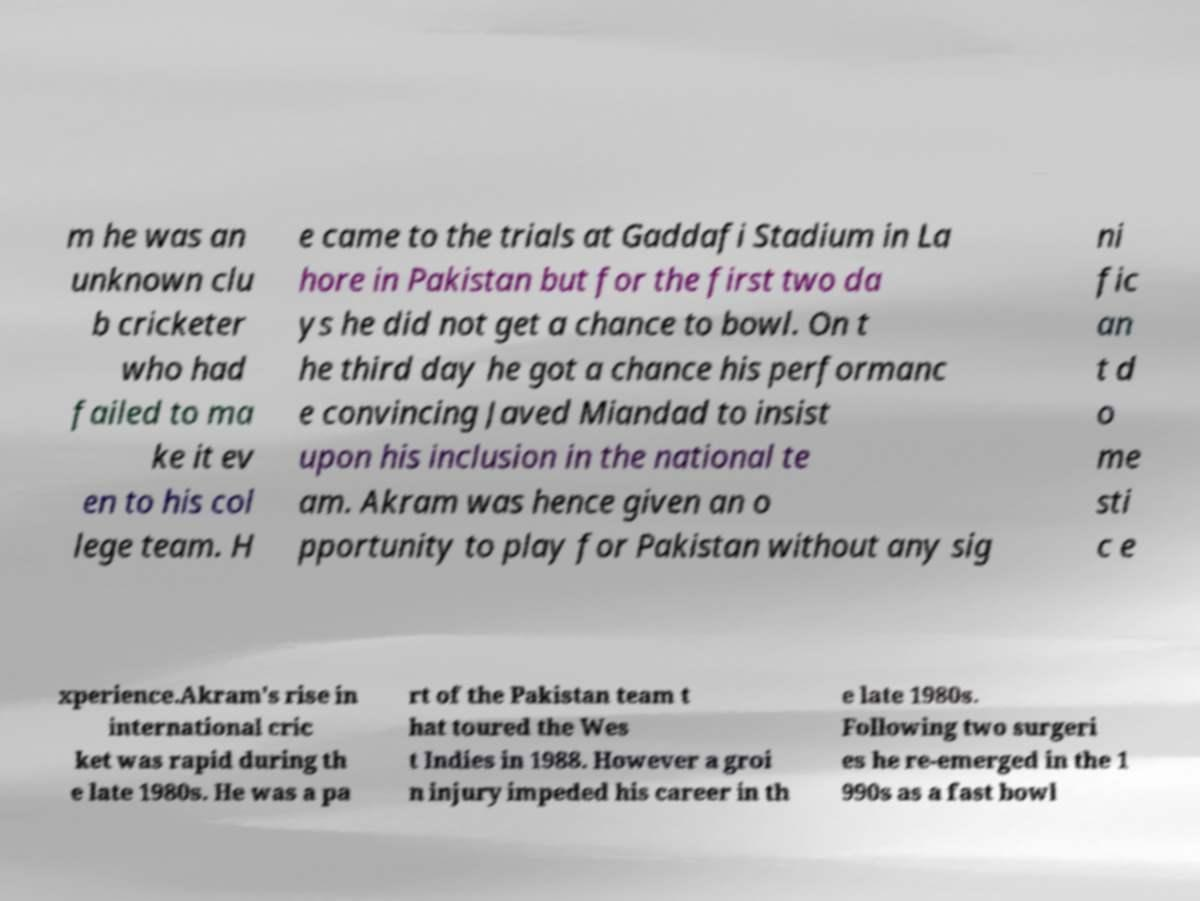Please read and relay the text visible in this image. What does it say? m he was an unknown clu b cricketer who had failed to ma ke it ev en to his col lege team. H e came to the trials at Gaddafi Stadium in La hore in Pakistan but for the first two da ys he did not get a chance to bowl. On t he third day he got a chance his performanc e convincing Javed Miandad to insist upon his inclusion in the national te am. Akram was hence given an o pportunity to play for Pakistan without any sig ni fic an t d o me sti c e xperience.Akram's rise in international cric ket was rapid during th e late 1980s. He was a pa rt of the Pakistan team t hat toured the Wes t Indies in 1988. However a groi n injury impeded his career in th e late 1980s. Following two surgeri es he re-emerged in the 1 990s as a fast bowl 